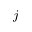Convert formula to latex. <formula><loc_0><loc_0><loc_500><loc_500>j</formula> 